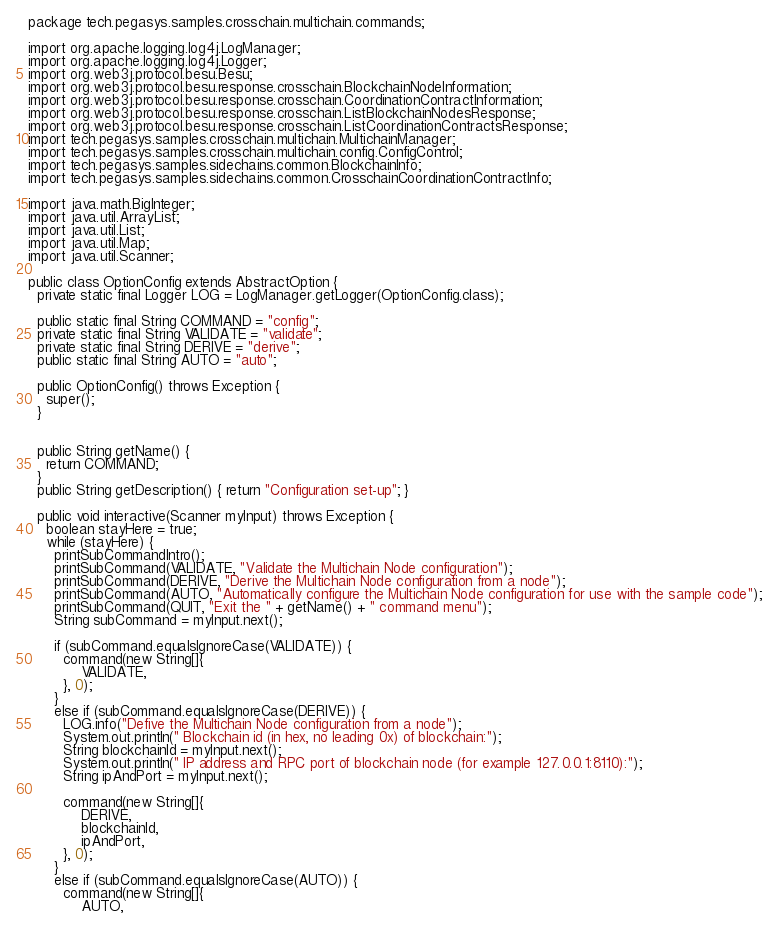Convert code to text. <code><loc_0><loc_0><loc_500><loc_500><_Java_>package tech.pegasys.samples.crosschain.multichain.commands;

import org.apache.logging.log4j.LogManager;
import org.apache.logging.log4j.Logger;
import org.web3j.protocol.besu.Besu;
import org.web3j.protocol.besu.response.crosschain.BlockchainNodeInformation;
import org.web3j.protocol.besu.response.crosschain.CoordinationContractInformation;
import org.web3j.protocol.besu.response.crosschain.ListBlockchainNodesResponse;
import org.web3j.protocol.besu.response.crosschain.ListCoordinationContractsResponse;
import tech.pegasys.samples.crosschain.multichain.MultichainManager;
import tech.pegasys.samples.crosschain.multichain.config.ConfigControl;
import tech.pegasys.samples.sidechains.common.BlockchainInfo;
import tech.pegasys.samples.sidechains.common.CrosschainCoordinationContractInfo;

import java.math.BigInteger;
import java.util.ArrayList;
import java.util.List;
import java.util.Map;
import java.util.Scanner;

public class OptionConfig extends AbstractOption {
  private static final Logger LOG = LogManager.getLogger(OptionConfig.class);

  public static final String COMMAND = "config";
  private static final String VALIDATE = "validate";
  private static final String DERIVE = "derive";
  public static final String AUTO = "auto";

  public OptionConfig() throws Exception {
    super();
  }


  public String getName() {
    return COMMAND;
  }
  public String getDescription() { return "Configuration set-up"; }

  public void interactive(Scanner myInput) throws Exception {
    boolean stayHere = true;
    while (stayHere) {
      printSubCommandIntro();
      printSubCommand(VALIDATE, "Validate the Multichain Node configuration");
      printSubCommand(DERIVE, "Derive the Multichain Node configuration from a node");
      printSubCommand(AUTO, "Automatically configure the Multichain Node configuration for use with the sample code");
      printSubCommand(QUIT, "Exit the " + getName() + " command menu");
      String subCommand = myInput.next();

      if (subCommand.equalsIgnoreCase(VALIDATE)) {
        command(new String[]{
            VALIDATE,
        }, 0);
      }
      else if (subCommand.equalsIgnoreCase(DERIVE)) {
        LOG.info("Defive the Multichain Node configuration from a node");
        System.out.println(" Blockchain id (in hex, no leading 0x) of blockchain:");
        String blockchainId = myInput.next();
        System.out.println(" IP address and RPC port of blockchain node (for example 127.0.0.1:8110):");
        String ipAndPort = myInput.next();

        command(new String[]{
            DERIVE,
            blockchainId,
            ipAndPort,
        }, 0);
      }
      else if (subCommand.equalsIgnoreCase(AUTO)) {
        command(new String[]{
            AUTO,</code> 